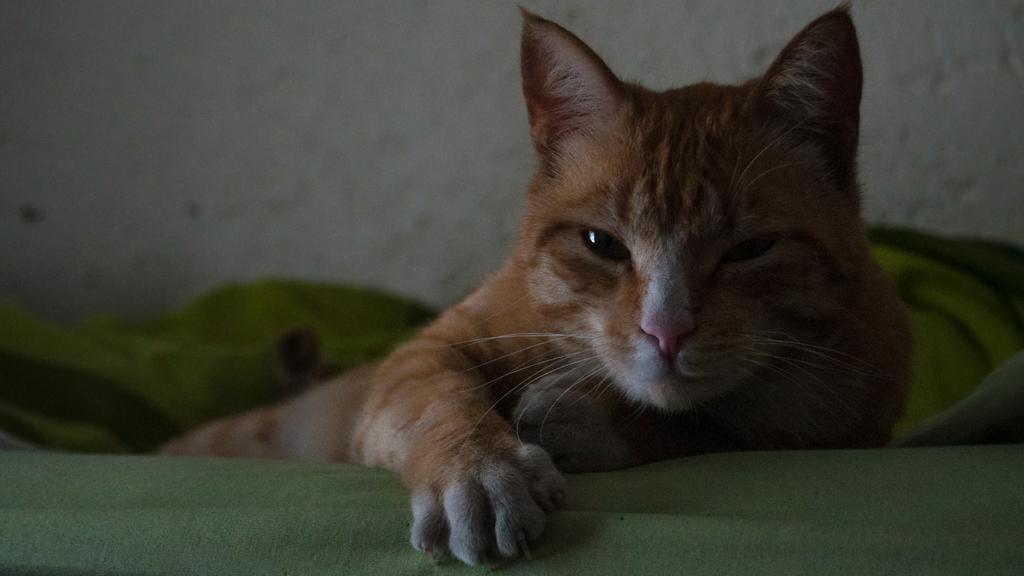What type of animal is on the couch in the image? There is a cat on the couch in the image. What can be seen behind the couch? There is a wall visible in the image. How many bikes are parked next to the cat on the couch? There are no bikes present in the image; it only features a cat on the couch and a wall in the background. 